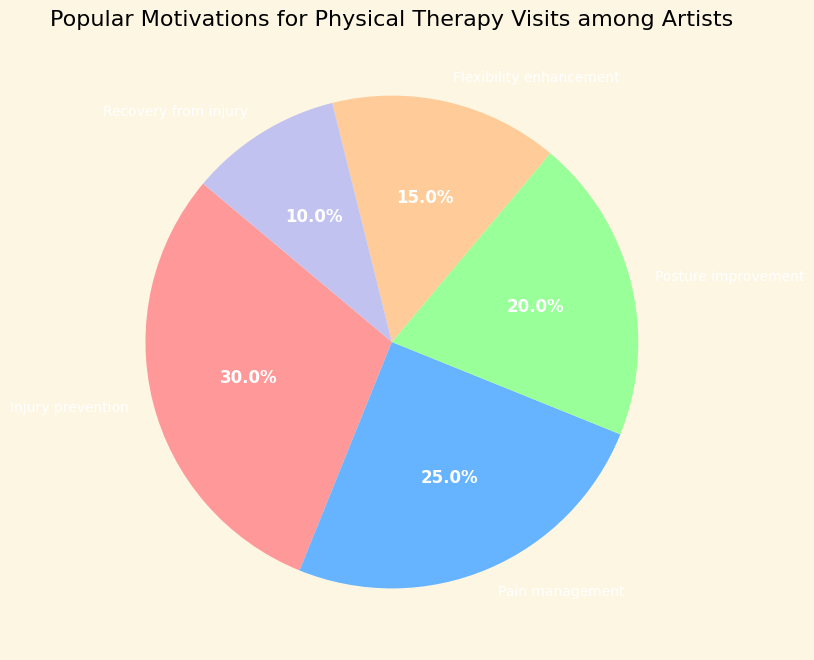What is the most common motivation for physical therapy visits among artists? The pie chart shows that the largest segment, representing 30%, is for Injury prevention. This is the highest percentage among all the listed motivations.
Answer: Injury prevention Which two motivations combined account for half of the physical therapy visits? Adding the percentages for Injury prevention (30%) and Pain management (25%) results in 55%, which is more than half. To achieve exactly half, we combine Posture improvement (20%) and Flexibility enhancement (15%), resulting in 50%.
Answer: Injury prevention and Pain management Compare the percentages of Pain management and Recovery from injury. Which is higher and by how much? The pie chart shows Pain management at 25% and Recovery from injury at 10%. The difference between them is 25% - 10% = 15%.
Answer: Pain management by 15% What percentage of physical therapy visits are for improving posture or enhancing flexibility? Adding the percentages for Posture improvement (20%) and Flexibility enhancement (15%) results in 20% + 15% = 35%.
Answer: 35% What is the least common motivation for physical therapy visits among artists, and what is its percentage? The pie chart indicates that the smallest segment, representing 10%, is for Recovery from injury.
Answer: Recovery from injury, 10% By how much does the percentage for Injury prevention exceed the percentage for Flexibility enhancement? From the pie chart, Injury prevention is 30% and Flexibility enhancement is 15%. The difference is 30% - 15% = 15%.
Answer: 15% How much more common is it for artists to visit physical therapists for Pain management compared to Flexibility enhancement? Pain management is at 25%, while Flexibility enhancement is at 15%. The difference is 25% - 15% = 10%.
Answer: 10% Sum the percentages of all motivations except Pain management. What does this add up to? Adding Injury prevention (30%), Posture improvement (20%), Flexibility enhancement (15%), and Recovery from injury (10%) results in 30% + 20% + 15% + 10% = 75%.
Answer: 75% 